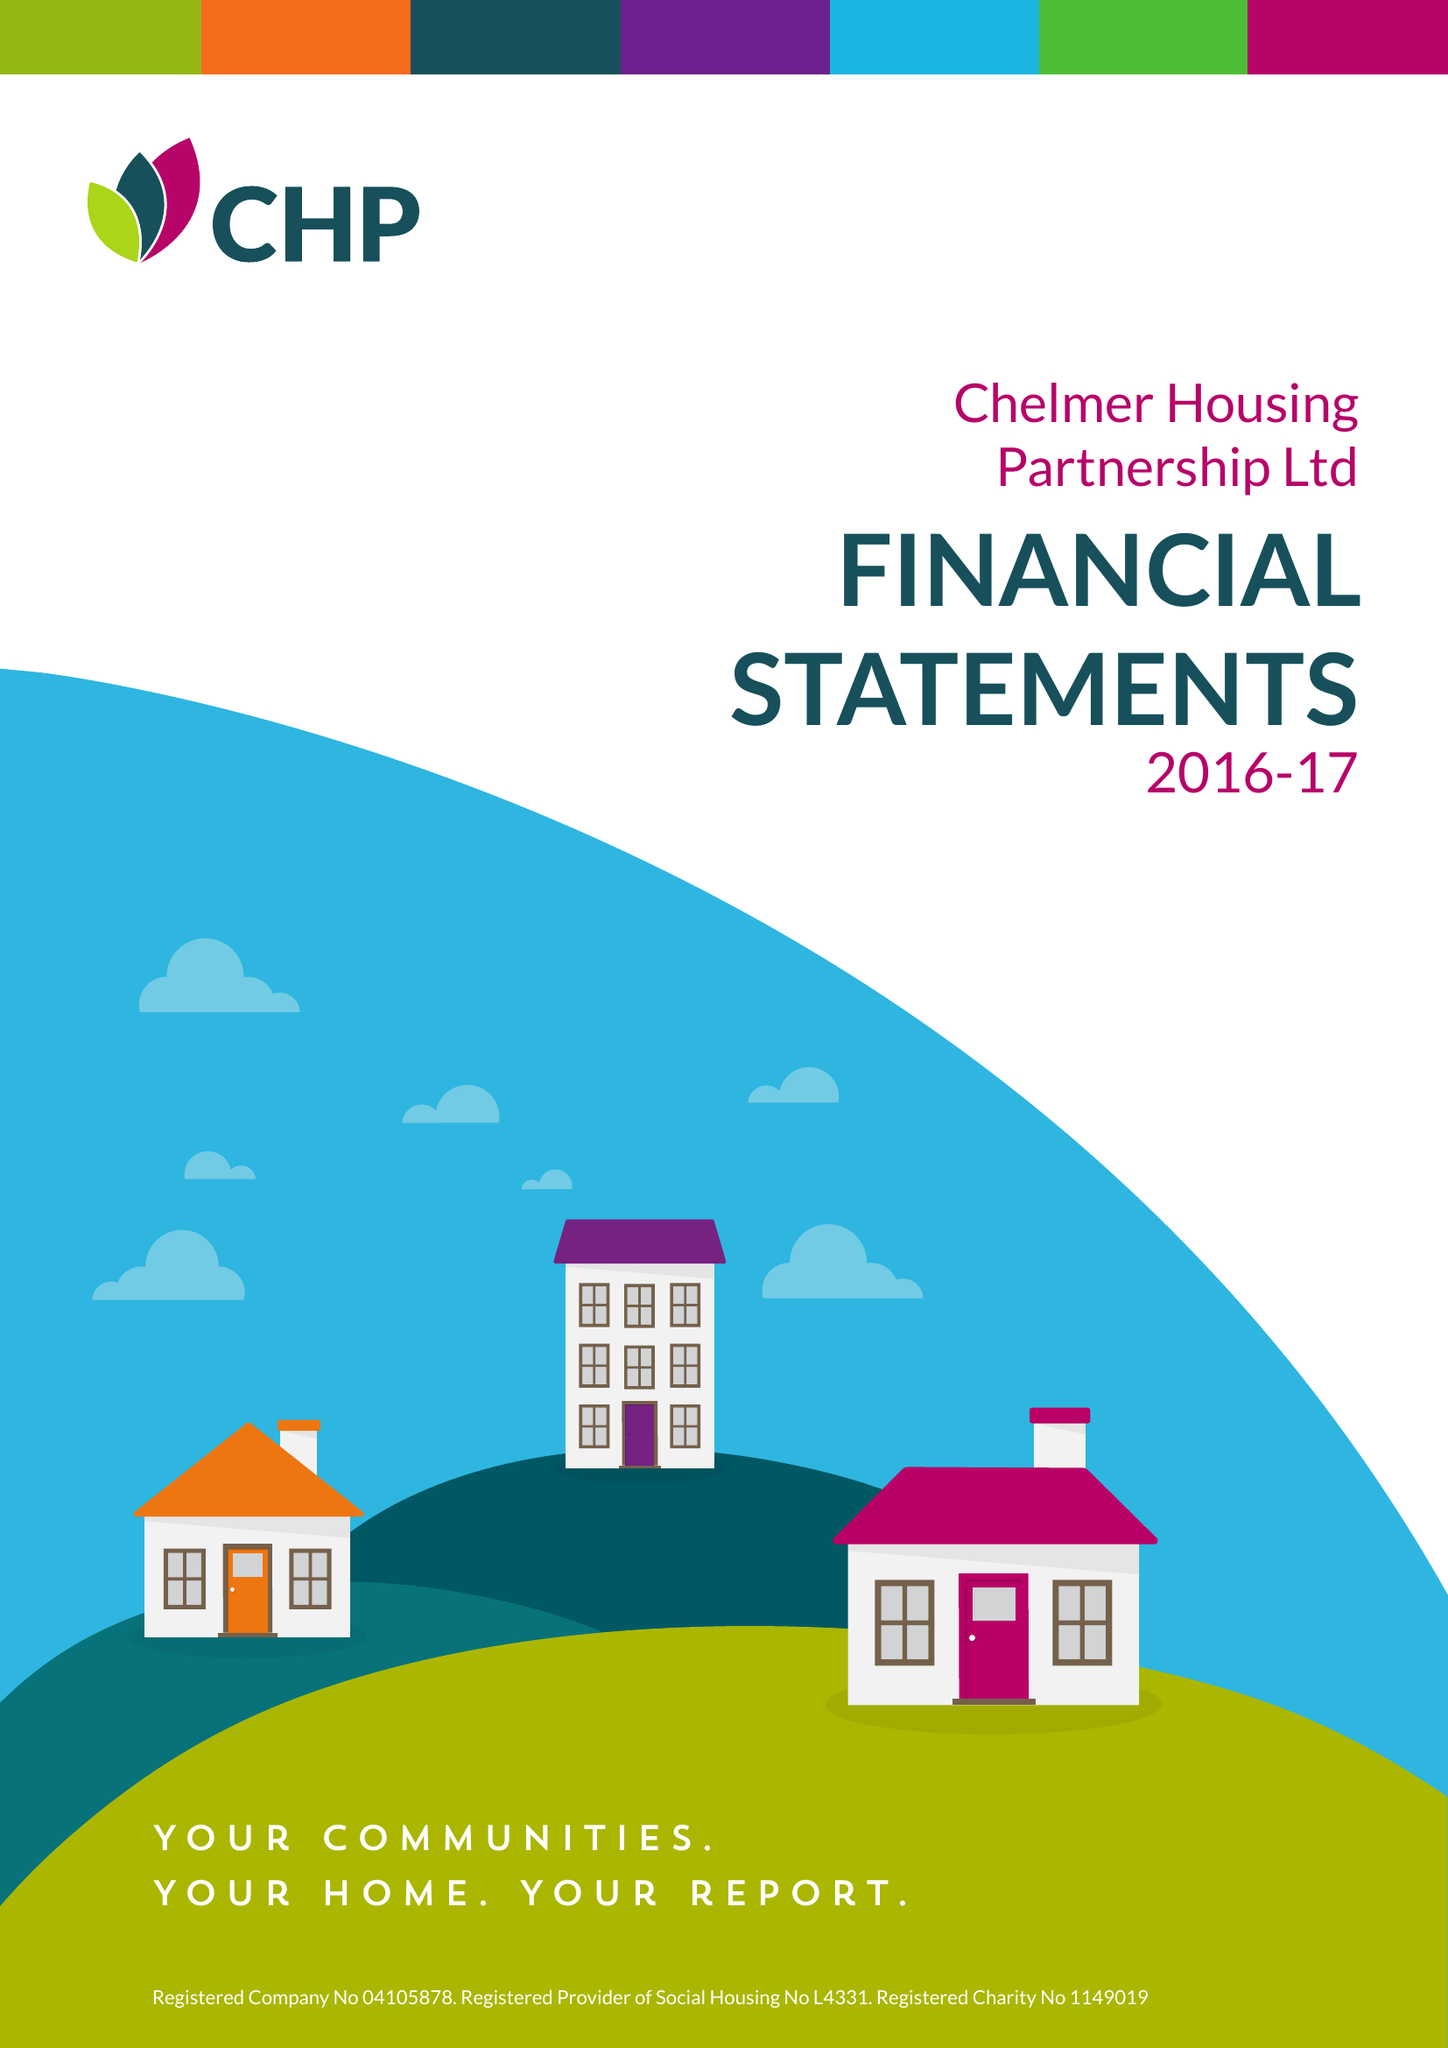What is the value for the address__post_town?
Answer the question using a single word or phrase. CHELMSFORD 